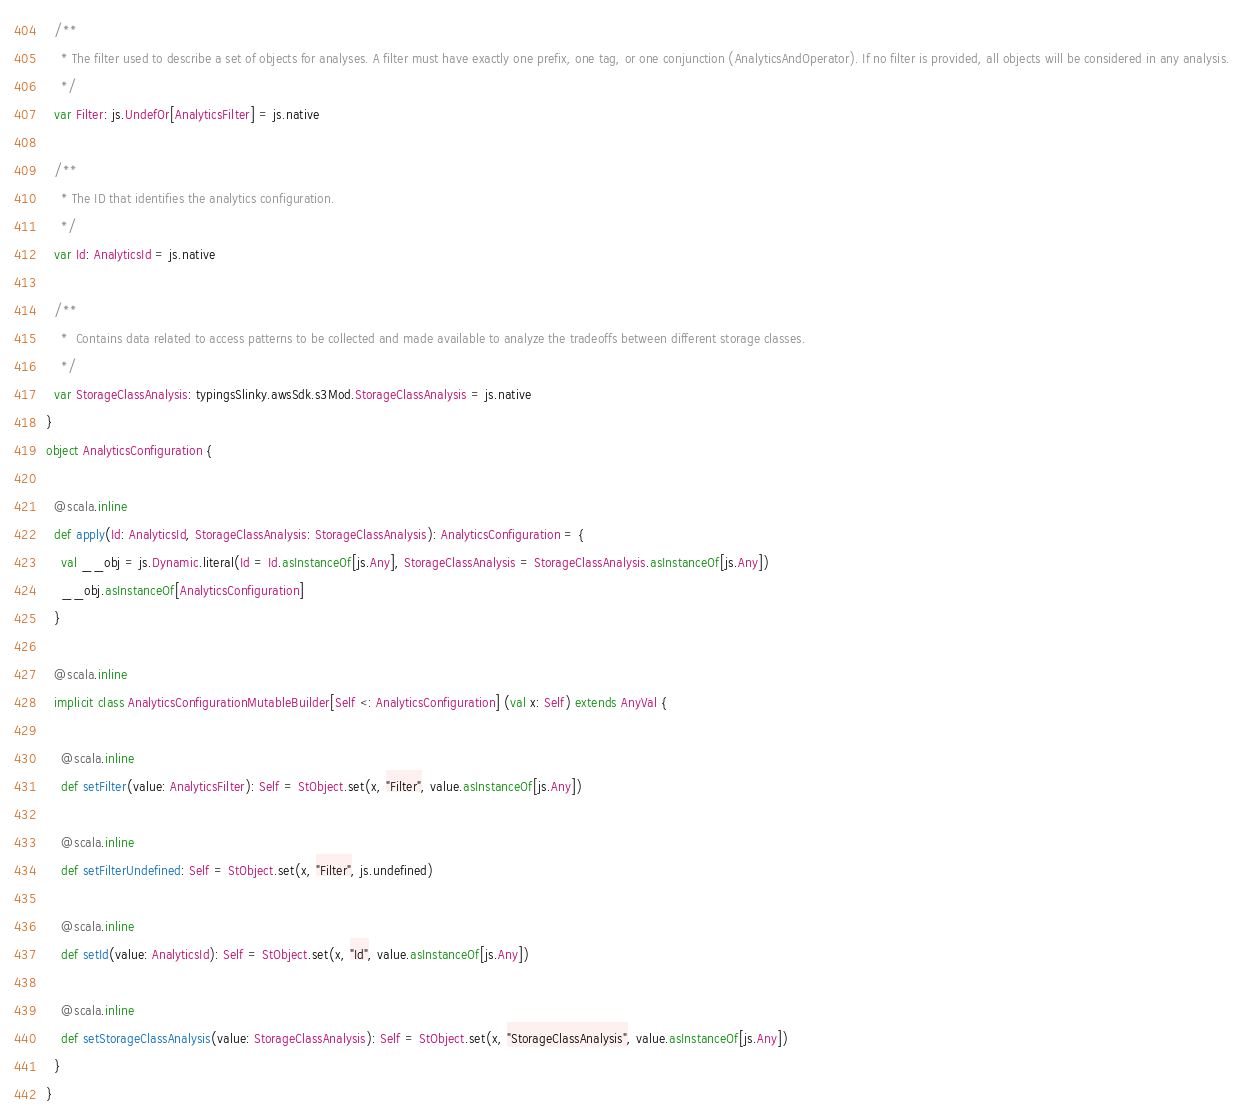Convert code to text. <code><loc_0><loc_0><loc_500><loc_500><_Scala_>  /**
    * The filter used to describe a set of objects for analyses. A filter must have exactly one prefix, one tag, or one conjunction (AnalyticsAndOperator). If no filter is provided, all objects will be considered in any analysis.
    */
  var Filter: js.UndefOr[AnalyticsFilter] = js.native
  
  /**
    * The ID that identifies the analytics configuration.
    */
  var Id: AnalyticsId = js.native
  
  /**
    *  Contains data related to access patterns to be collected and made available to analyze the tradeoffs between different storage classes. 
    */
  var StorageClassAnalysis: typingsSlinky.awsSdk.s3Mod.StorageClassAnalysis = js.native
}
object AnalyticsConfiguration {
  
  @scala.inline
  def apply(Id: AnalyticsId, StorageClassAnalysis: StorageClassAnalysis): AnalyticsConfiguration = {
    val __obj = js.Dynamic.literal(Id = Id.asInstanceOf[js.Any], StorageClassAnalysis = StorageClassAnalysis.asInstanceOf[js.Any])
    __obj.asInstanceOf[AnalyticsConfiguration]
  }
  
  @scala.inline
  implicit class AnalyticsConfigurationMutableBuilder[Self <: AnalyticsConfiguration] (val x: Self) extends AnyVal {
    
    @scala.inline
    def setFilter(value: AnalyticsFilter): Self = StObject.set(x, "Filter", value.asInstanceOf[js.Any])
    
    @scala.inline
    def setFilterUndefined: Self = StObject.set(x, "Filter", js.undefined)
    
    @scala.inline
    def setId(value: AnalyticsId): Self = StObject.set(x, "Id", value.asInstanceOf[js.Any])
    
    @scala.inline
    def setStorageClassAnalysis(value: StorageClassAnalysis): Self = StObject.set(x, "StorageClassAnalysis", value.asInstanceOf[js.Any])
  }
}
</code> 